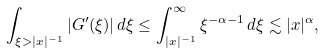<formula> <loc_0><loc_0><loc_500><loc_500>\int _ { \xi > | x | ^ { - 1 } } | G ^ { \prime } ( \xi ) | \, d \xi \leq \int _ { | x | ^ { - 1 } } ^ { \infty } \xi ^ { - \alpha - 1 } \, d \xi \lesssim | x | ^ { \alpha } ,</formula> 